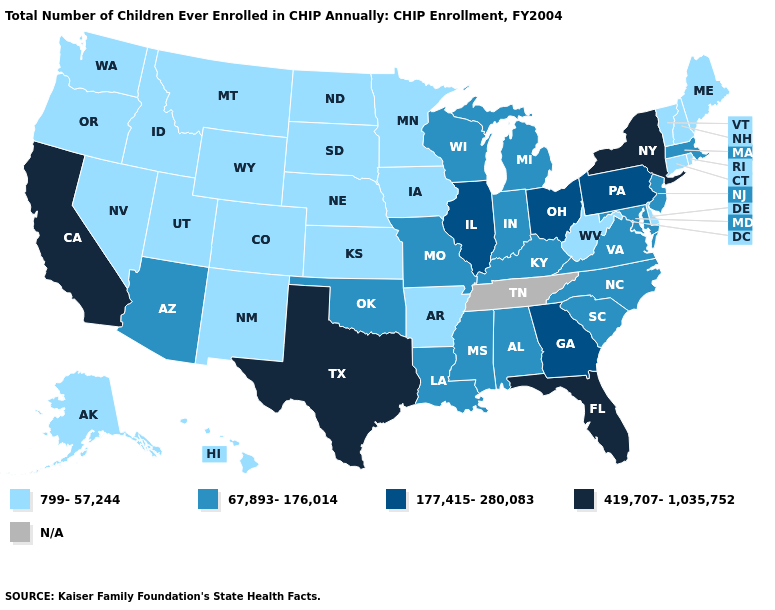What is the value of Connecticut?
Write a very short answer. 799-57,244. What is the value of Massachusetts?
Quick response, please. 67,893-176,014. What is the lowest value in the South?
Keep it brief. 799-57,244. Name the states that have a value in the range 799-57,244?
Quick response, please. Alaska, Arkansas, Colorado, Connecticut, Delaware, Hawaii, Idaho, Iowa, Kansas, Maine, Minnesota, Montana, Nebraska, Nevada, New Hampshire, New Mexico, North Dakota, Oregon, Rhode Island, South Dakota, Utah, Vermont, Washington, West Virginia, Wyoming. Name the states that have a value in the range 177,415-280,083?
Concise answer only. Georgia, Illinois, Ohio, Pennsylvania. What is the value of Washington?
Be succinct. 799-57,244. Among the states that border Massachusetts , which have the highest value?
Answer briefly. New York. Name the states that have a value in the range 67,893-176,014?
Short answer required. Alabama, Arizona, Indiana, Kentucky, Louisiana, Maryland, Massachusetts, Michigan, Mississippi, Missouri, New Jersey, North Carolina, Oklahoma, South Carolina, Virginia, Wisconsin. What is the value of Iowa?
Short answer required. 799-57,244. Name the states that have a value in the range N/A?
Quick response, please. Tennessee. What is the value of Delaware?
Quick response, please. 799-57,244. What is the highest value in the USA?
Write a very short answer. 419,707-1,035,752. What is the lowest value in the USA?
Keep it brief. 799-57,244. 